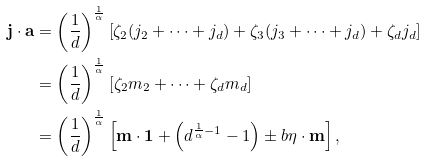<formula> <loc_0><loc_0><loc_500><loc_500>\mathbf j \cdot \mathbf a & = \left ( \frac { 1 } { d } \right ) ^ { \frac { 1 } { \alpha } } \left [ \zeta _ { 2 } ( j _ { 2 } + \cdots + j _ { d } ) + \zeta _ { 3 } ( j _ { 3 } + \cdots + j _ { d } ) + \zeta _ { d } j _ { d } \right ] \\ & = \left ( \frac { 1 } { d } \right ) ^ { \frac { 1 } { \alpha } } [ \zeta _ { 2 } m _ { 2 } + \cdots + \zeta _ { d } m _ { d } ] \\ & = \left ( \frac { 1 } { d } \right ) ^ { \frac { 1 } { \alpha } } \left [ \mathbf m \cdot \mathbf 1 + \left ( d ^ { \frac { 1 } { \alpha } - 1 } - 1 \right ) \pm b { \eta } \cdot \mathbf m \right ] ,</formula> 